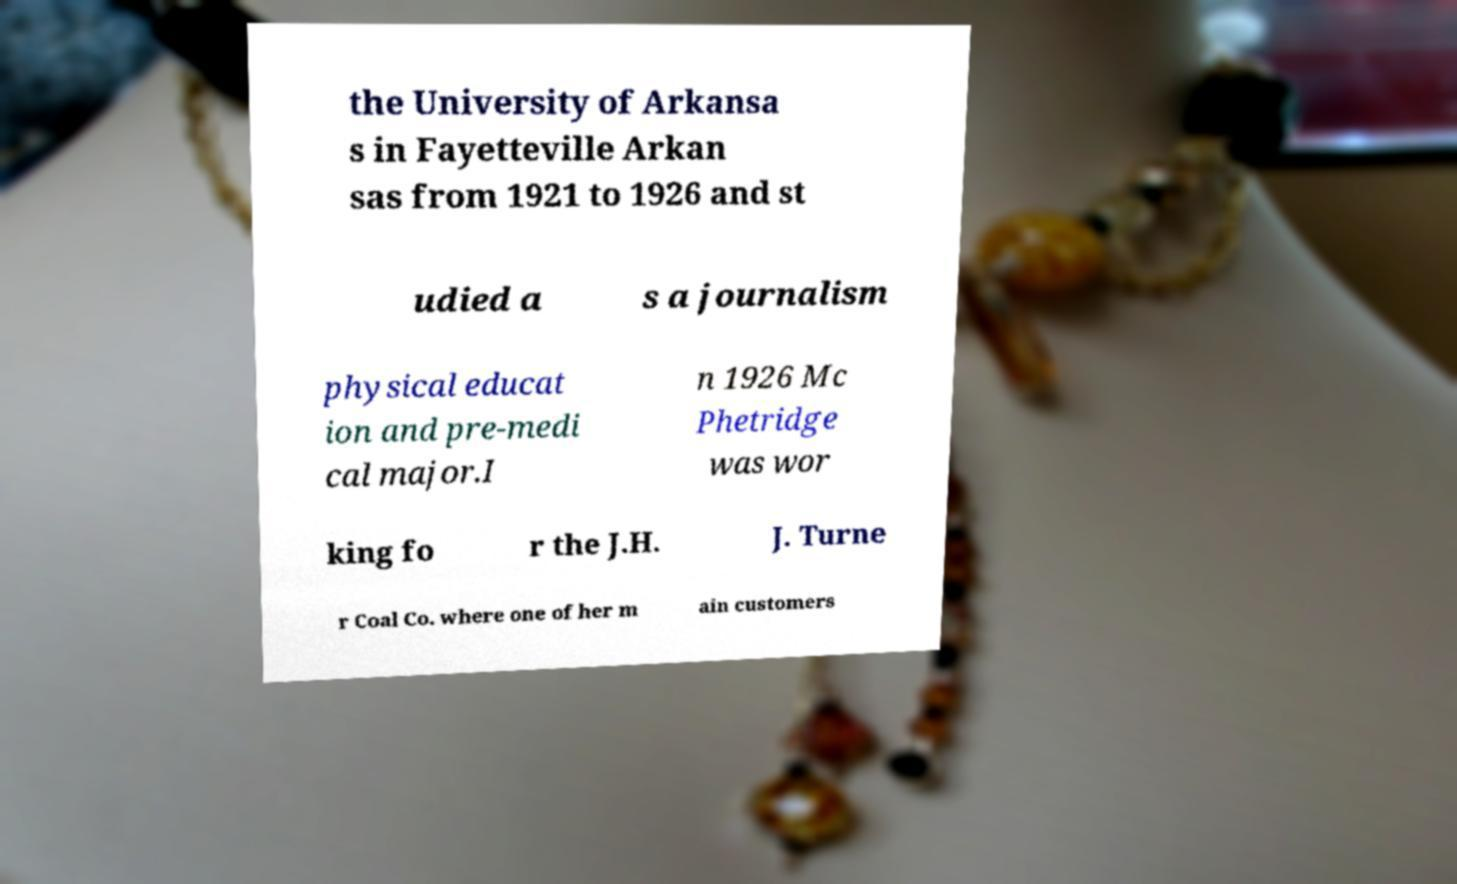Please read and relay the text visible in this image. What does it say? the University of Arkansa s in Fayetteville Arkan sas from 1921 to 1926 and st udied a s a journalism physical educat ion and pre-medi cal major.I n 1926 Mc Phetridge was wor king fo r the J.H. J. Turne r Coal Co. where one of her m ain customers 